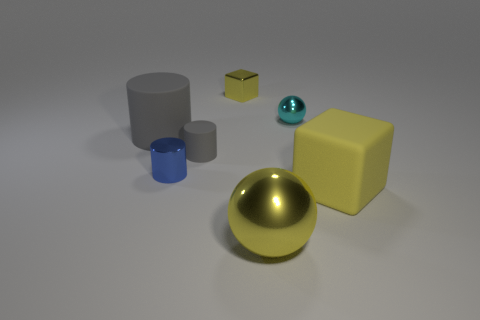What material is the other thing that is the same color as the small rubber object?
Make the answer very short. Rubber. What size is the rubber thing that is the same color as the small matte cylinder?
Your answer should be compact. Large. How many objects are big gray rubber cylinders or matte objects that are right of the tiny blue cylinder?
Provide a short and direct response. 3. What number of other things are there of the same shape as the small cyan metal object?
Your answer should be very brief. 1. Is the number of metal blocks to the right of the big yellow rubber object less than the number of big cylinders on the right side of the small gray object?
Provide a succinct answer. No. Are there any other things that have the same material as the small blue cylinder?
Offer a terse response. Yes. What is the shape of the large object that is made of the same material as the tiny yellow block?
Keep it short and to the point. Sphere. Are there any other things that are the same color as the large cube?
Ensure brevity in your answer.  Yes. There is a sphere that is behind the yellow cube right of the cyan sphere; what color is it?
Offer a terse response. Cyan. What is the material of the large yellow thing behind the shiny sphere that is left of the shiny sphere that is behind the large yellow metallic ball?
Your response must be concise. Rubber. 